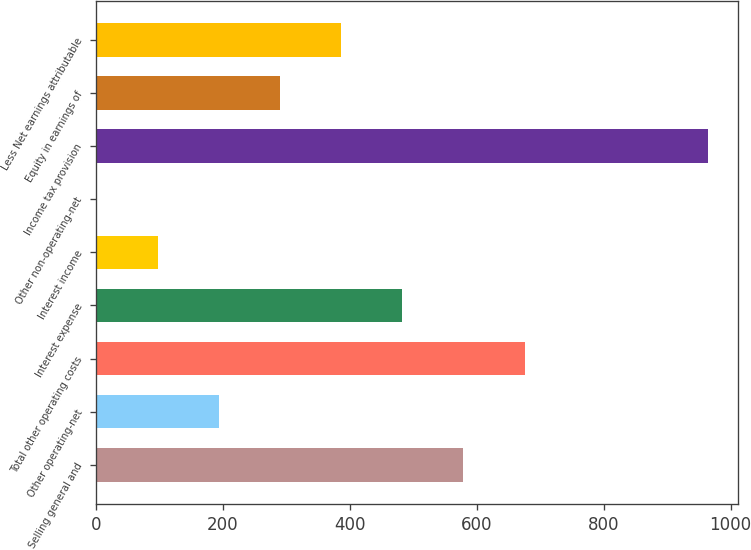Convert chart. <chart><loc_0><loc_0><loc_500><loc_500><bar_chart><fcel>Selling general and<fcel>Other operating-net<fcel>Total other operating costs<fcel>Interest expense<fcel>Interest income<fcel>Other non-operating-net<fcel>Income tax provision<fcel>Equity in earnings of<fcel>Less Net earnings attributable<nl><fcel>578.96<fcel>193.72<fcel>675.27<fcel>482.65<fcel>97.41<fcel>1.1<fcel>964.2<fcel>290.03<fcel>386.34<nl></chart> 